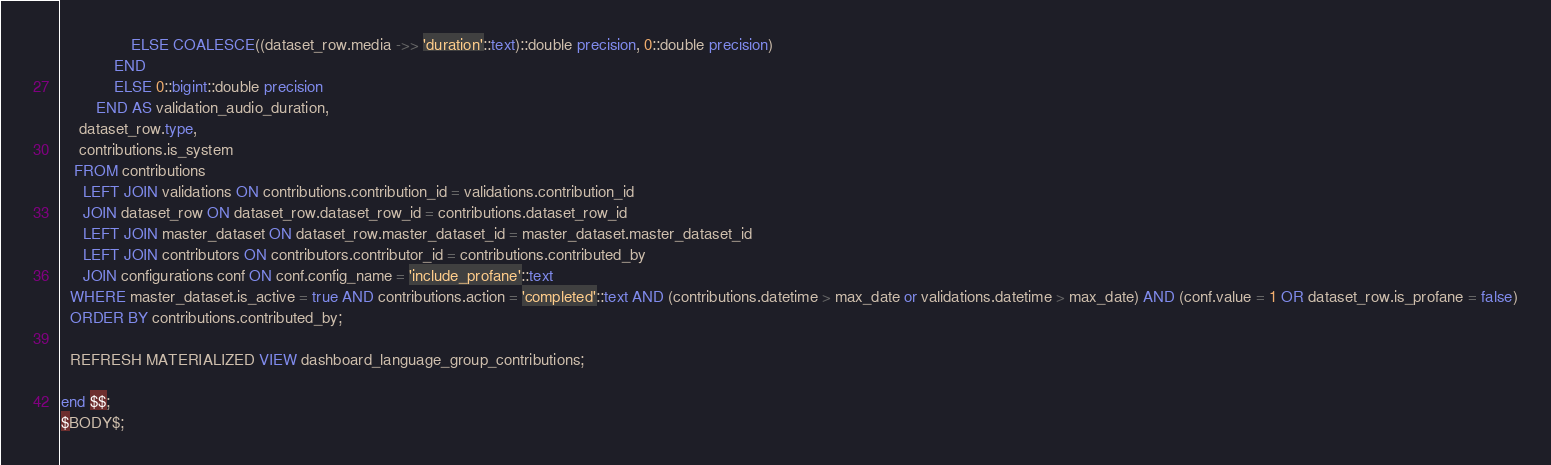Convert code to text. <code><loc_0><loc_0><loc_500><loc_500><_SQL_>                ELSE COALESCE((dataset_row.media ->> 'duration'::text)::double precision, 0::double precision)
            END
            ELSE 0::bigint::double precision
        END AS validation_audio_duration,
    dataset_row.type,
    contributions.is_system
   FROM contributions
     LEFT JOIN validations ON contributions.contribution_id = validations.contribution_id
     JOIN dataset_row ON dataset_row.dataset_row_id = contributions.dataset_row_id
	 LEFT JOIN master_dataset ON dataset_row.master_dataset_id = master_dataset.master_dataset_id
     LEFT JOIN contributors ON contributors.contributor_id = contributions.contributed_by
     JOIN configurations conf ON conf.config_name = 'include_profane'::text
  WHERE master_dataset.is_active = true AND contributions.action = 'completed'::text AND (contributions.datetime > max_date or validations.datetime > max_date) AND (conf.value = 1 OR dataset_row.is_profane = false)
  ORDER BY contributions.contributed_by;

  REFRESH MATERIALIZED VIEW dashboard_language_group_contributions;
  
end $$;
$BODY$;</code> 